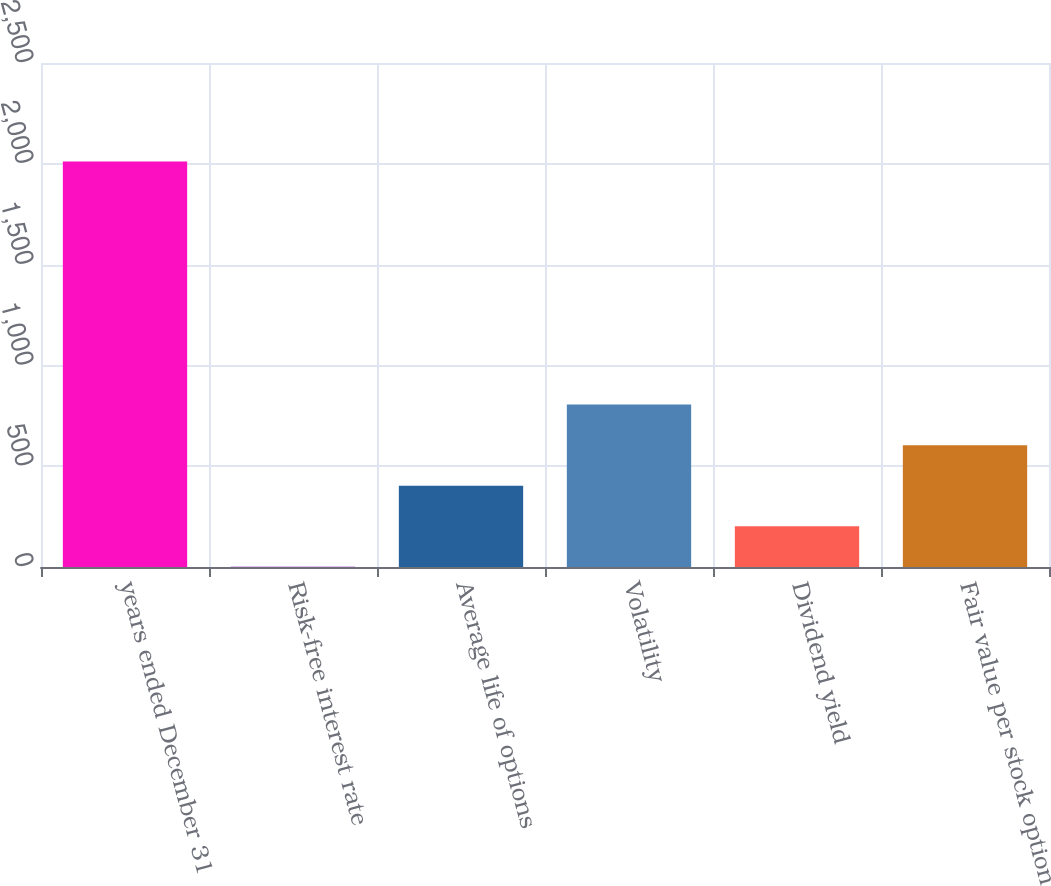Convert chart to OTSL. <chart><loc_0><loc_0><loc_500><loc_500><bar_chart><fcel>years ended December 31<fcel>Risk-free interest rate<fcel>Average life of options<fcel>Volatility<fcel>Dividend yield<fcel>Fair value per stock option<nl><fcel>2012<fcel>1.2<fcel>403.36<fcel>805.52<fcel>202.28<fcel>604.44<nl></chart> 